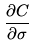Convert formula to latex. <formula><loc_0><loc_0><loc_500><loc_500>\frac { \partial C } { \partial \sigma }</formula> 